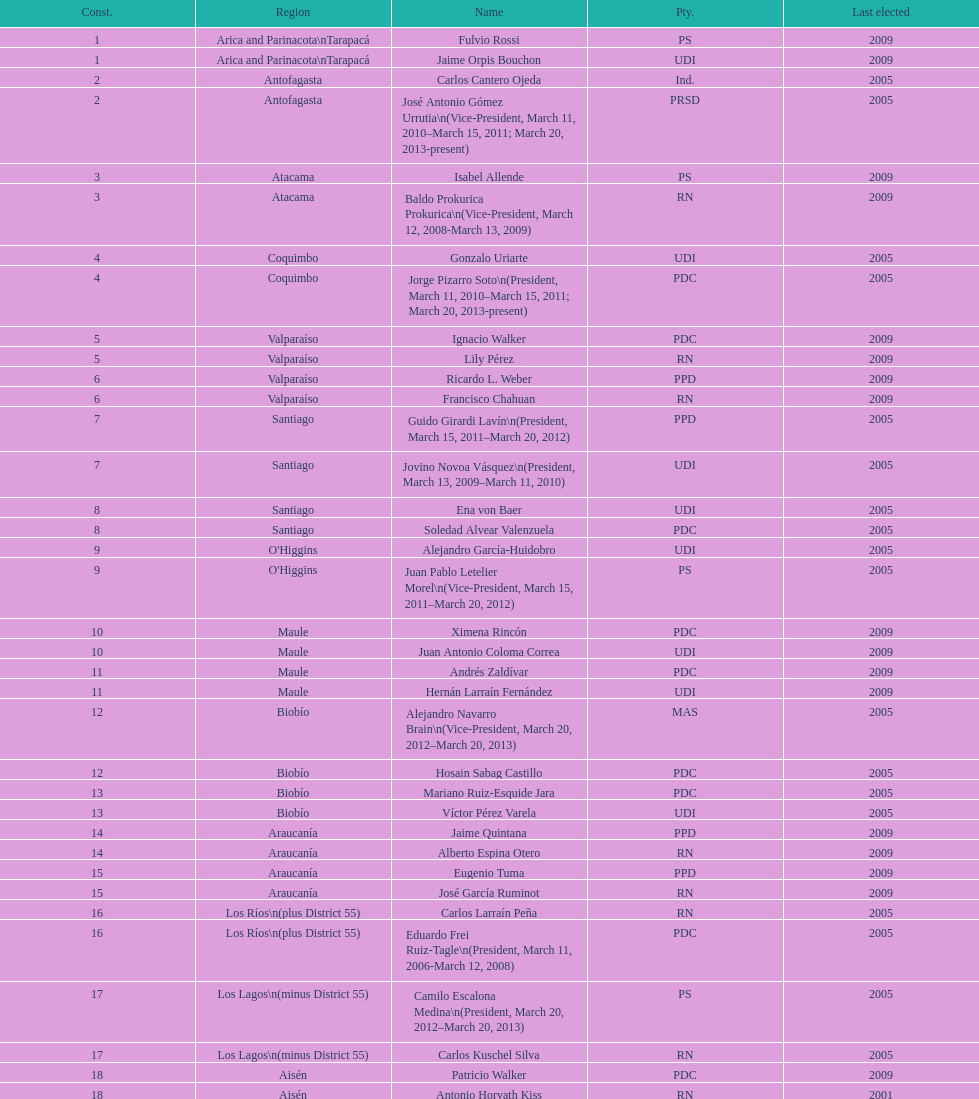When was antonio horvath kiss last elected? 2001. 